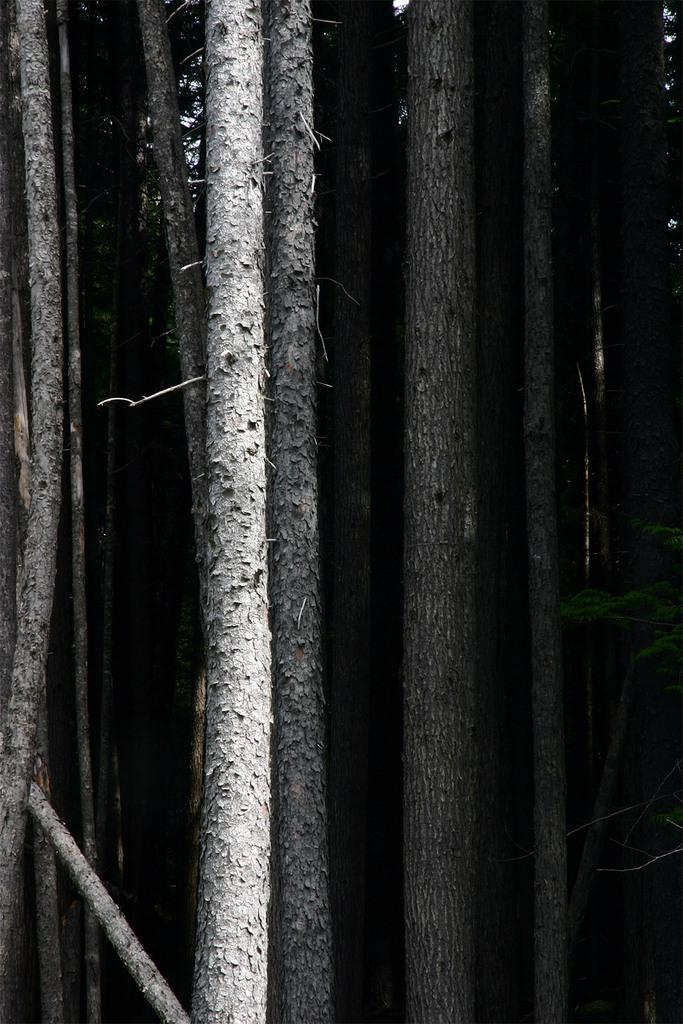What type of vegetation can be seen in the image? There are trees in the image. What type of cheese is being used to make the beds in the image? There is no cheese or beds present in the image; it only features trees. 